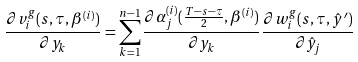<formula> <loc_0><loc_0><loc_500><loc_500>\frac { \partial v _ { i } ^ { g } ( s , \tau , \beta ^ { ( i ) } ) } { \partial y _ { k } } = \sum _ { k = 1 } ^ { n - 1 } \frac { \partial \alpha _ { j } ^ { ( i ) } ( \frac { T - s - \tau } { 2 } , \beta ^ { ( i ) } ) } { \partial y _ { k } } \frac { \partial w _ { i } ^ { g } ( s , \tau , \hat { y } ^ { \prime } ) } { \partial \hat { y } _ { j } }</formula> 